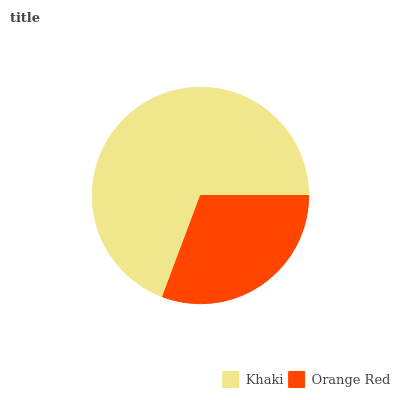Is Orange Red the minimum?
Answer yes or no. Yes. Is Khaki the maximum?
Answer yes or no. Yes. Is Orange Red the maximum?
Answer yes or no. No. Is Khaki greater than Orange Red?
Answer yes or no. Yes. Is Orange Red less than Khaki?
Answer yes or no. Yes. Is Orange Red greater than Khaki?
Answer yes or no. No. Is Khaki less than Orange Red?
Answer yes or no. No. Is Khaki the high median?
Answer yes or no. Yes. Is Orange Red the low median?
Answer yes or no. Yes. Is Orange Red the high median?
Answer yes or no. No. Is Khaki the low median?
Answer yes or no. No. 